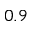<formula> <loc_0><loc_0><loc_500><loc_500>0 . 9</formula> 